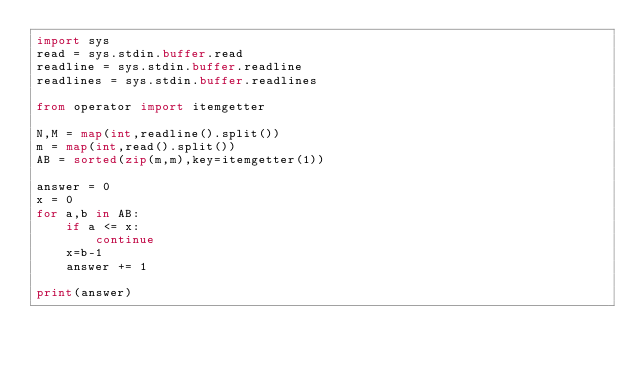Convert code to text. <code><loc_0><loc_0><loc_500><loc_500><_Python_>import sys
read = sys.stdin.buffer.read
readline = sys.stdin.buffer.readline
readlines = sys.stdin.buffer.readlines

from operator import itemgetter

N,M = map(int,readline().split())
m = map(int,read().split())
AB = sorted(zip(m,m),key=itemgetter(1))

answer = 0
x = 0
for a,b in AB:
    if a <= x:
        continue
    x=b-1
    answer += 1

print(answer)</code> 